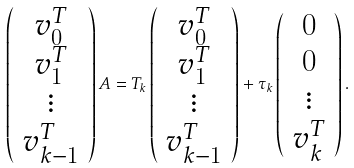<formula> <loc_0><loc_0><loc_500><loc_500>\left ( \begin{array} { c } v _ { 0 } ^ { T } \\ v _ { 1 } ^ { T } \\ \vdots \\ v _ { k - 1 } ^ { T } \end{array} \right ) A = T _ { k } \left ( \begin{array} { c } v _ { 0 } ^ { T } \\ v _ { 1 } ^ { T } \\ \vdots \\ v _ { k - 1 } ^ { T } \end{array} \right ) + \tau _ { k } \left ( \begin{array} { c } 0 \\ 0 \\ \vdots \\ v _ { k } ^ { T } \end{array} \right ) .</formula> 